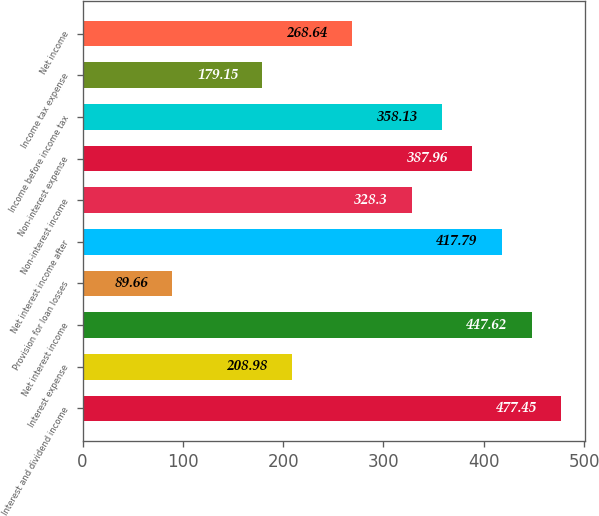Convert chart. <chart><loc_0><loc_0><loc_500><loc_500><bar_chart><fcel>Interest and dividend income<fcel>Interest expense<fcel>Net interest income<fcel>Provision for loan losses<fcel>Net interest income after<fcel>Non-interest income<fcel>Non-interest expense<fcel>Income before income tax<fcel>Income tax expense<fcel>Net income<nl><fcel>477.45<fcel>208.98<fcel>447.62<fcel>89.66<fcel>417.79<fcel>328.3<fcel>387.96<fcel>358.13<fcel>179.15<fcel>268.64<nl></chart> 